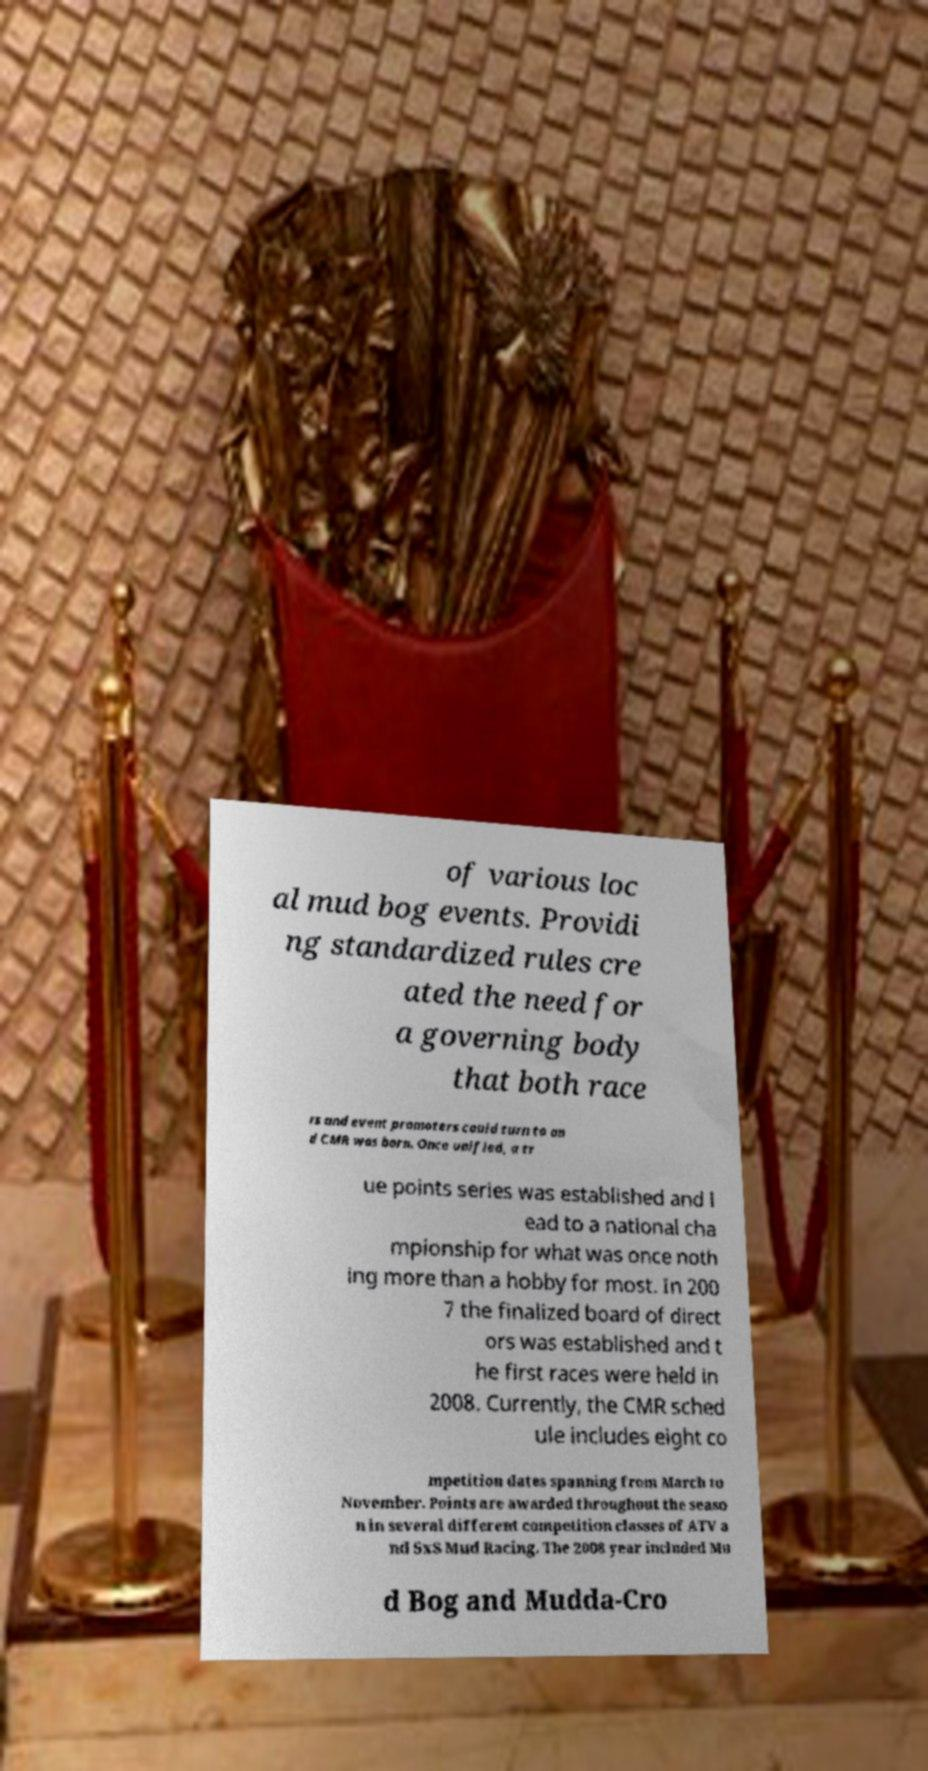For documentation purposes, I need the text within this image transcribed. Could you provide that? of various loc al mud bog events. Providi ng standardized rules cre ated the need for a governing body that both race rs and event promoters could turn to an d CMR was born. Once unified, a tr ue points series was established and l ead to a national cha mpionship for what was once noth ing more than a hobby for most. In 200 7 the finalized board of direct ors was established and t he first races were held in 2008. Currently, the CMR sched ule includes eight co mpetition dates spanning from March to November. Points are awarded throughout the seaso n in several different competition classes of ATV a nd SxS Mud Racing. The 2008 year included Mu d Bog and Mudda-Cro 